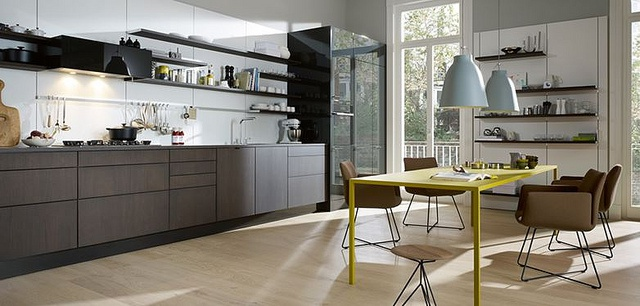Describe the objects in this image and their specific colors. I can see refrigerator in darkgray, black, and gray tones, oven in darkgray, gray, and black tones, dining table in darkgray, olive, and tan tones, chair in darkgray, black, maroon, and lightgray tones, and chair in darkgray, black, and lightgray tones in this image. 